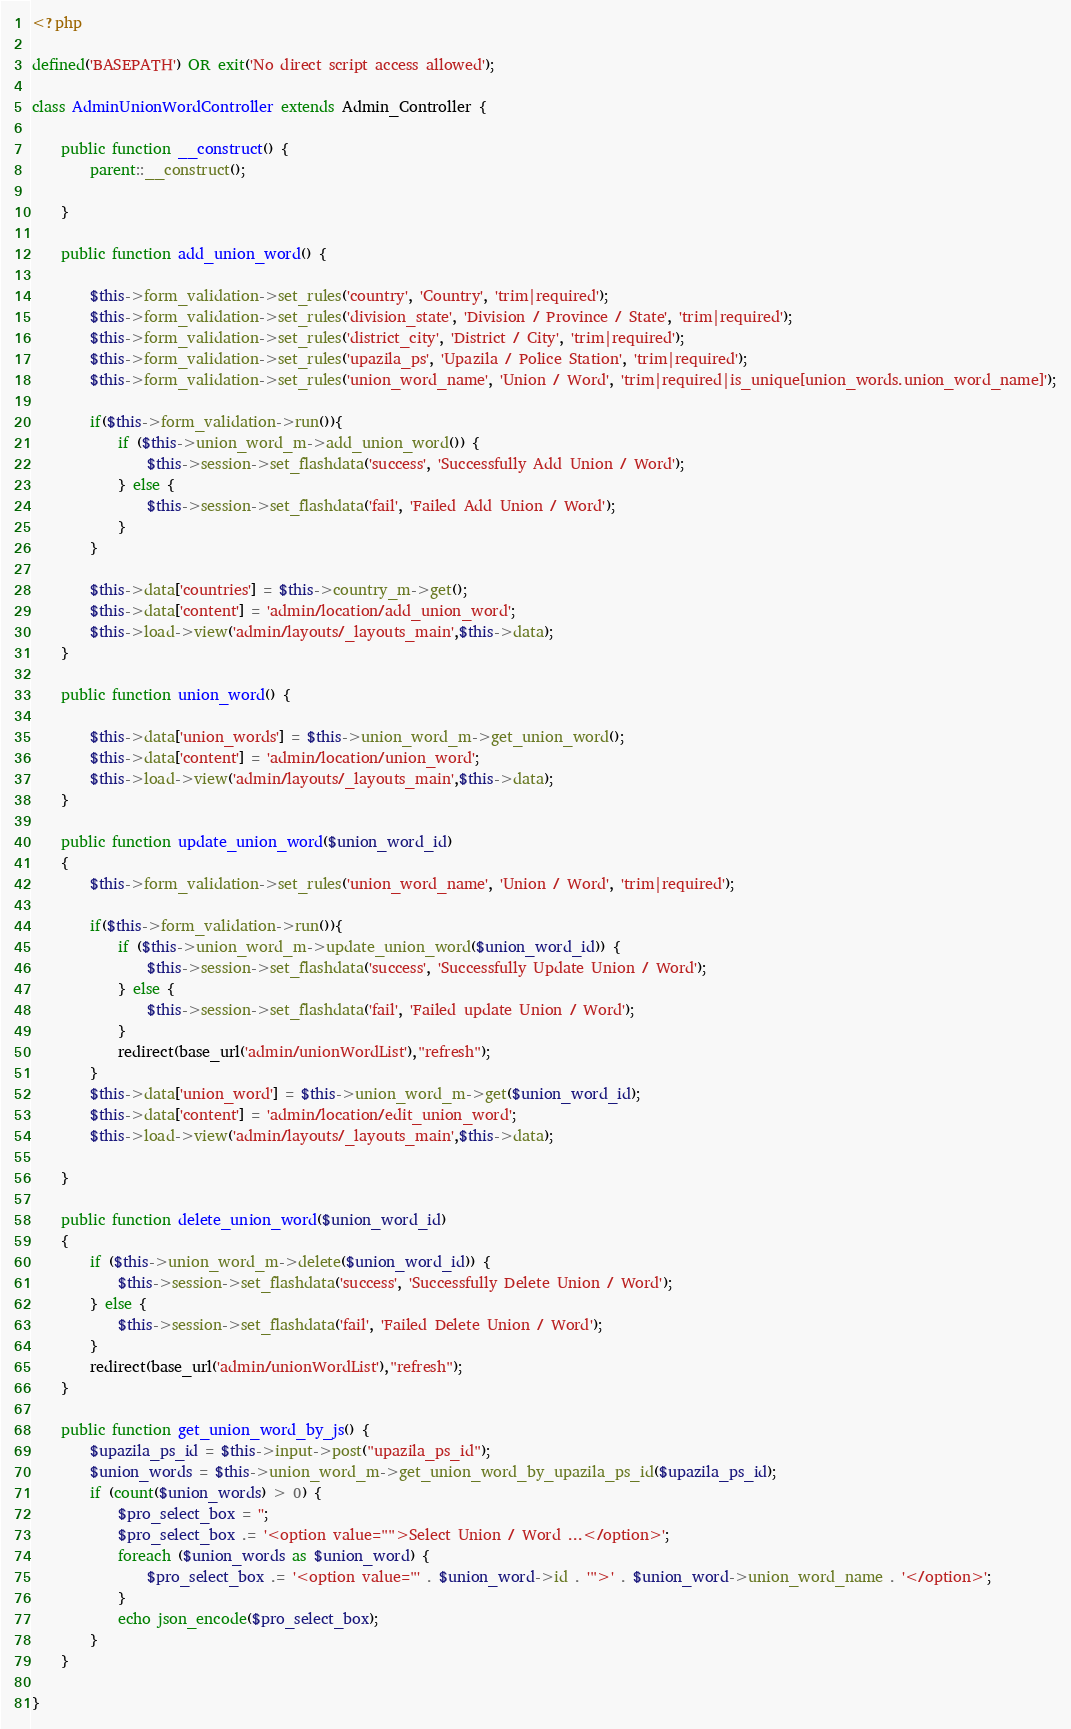<code> <loc_0><loc_0><loc_500><loc_500><_PHP_><?php

defined('BASEPATH') OR exit('No direct script access allowed');

class AdminUnionWordController extends Admin_Controller {

    public function __construct() {
        parent::__construct();

    }

    public function add_union_word() {

        $this->form_validation->set_rules('country', 'Country', 'trim|required');
        $this->form_validation->set_rules('division_state', 'Division / Province / State', 'trim|required');
        $this->form_validation->set_rules('district_city', 'District / City', 'trim|required');
        $this->form_validation->set_rules('upazila_ps', 'Upazila / Police Station', 'trim|required');
        $this->form_validation->set_rules('union_word_name', 'Union / Word', 'trim|required|is_unique[union_words.union_word_name]');

        if($this->form_validation->run()){
            if ($this->union_word_m->add_union_word()) {
                $this->session->set_flashdata('success', 'Successfully Add Union / Word');
            } else {
                $this->session->set_flashdata('fail', 'Failed Add Union / Word');
            }
        }

        $this->data['countries'] = $this->country_m->get();
        $this->data['content'] = 'admin/location/add_union_word';
        $this->load->view('admin/layouts/_layouts_main',$this->data);
    }

    public function union_word() {

        $this->data['union_words'] = $this->union_word_m->get_union_word();
        $this->data['content'] = 'admin/location/union_word';
        $this->load->view('admin/layouts/_layouts_main',$this->data);
    }

    public function update_union_word($union_word_id)
    {
        $this->form_validation->set_rules('union_word_name', 'Union / Word', 'trim|required');

        if($this->form_validation->run()){
            if ($this->union_word_m->update_union_word($union_word_id)) {
                $this->session->set_flashdata('success', 'Successfully Update Union / Word');
            } else {
                $this->session->set_flashdata('fail', 'Failed update Union / Word');
            }
            redirect(base_url('admin/unionWordList'),"refresh");
        }
        $this->data['union_word'] = $this->union_word_m->get($union_word_id);
        $this->data['content'] = 'admin/location/edit_union_word';
        $this->load->view('admin/layouts/_layouts_main',$this->data);

    }

    public function delete_union_word($union_word_id)
    {
        if ($this->union_word_m->delete($union_word_id)) {
            $this->session->set_flashdata('success', 'Successfully Delete Union / Word');
        } else {
            $this->session->set_flashdata('fail', 'Failed Delete Union / Word');
        }
        redirect(base_url('admin/unionWordList'),"refresh");
    }

    public function get_union_word_by_js() {
        $upazila_ps_id = $this->input->post("upazila_ps_id");
        $union_words = $this->union_word_m->get_union_word_by_upazila_ps_id($upazila_ps_id);
        if (count($union_words) > 0) {
            $pro_select_box = '';
            $pro_select_box .= '<option value="">Select Union / Word ...</option>';
            foreach ($union_words as $union_word) {
                $pro_select_box .= '<option value="' . $union_word->id . '">' . $union_word->union_word_name . '</option>';
            }
            echo json_encode($pro_select_box);
        }
    }

}
</code> 